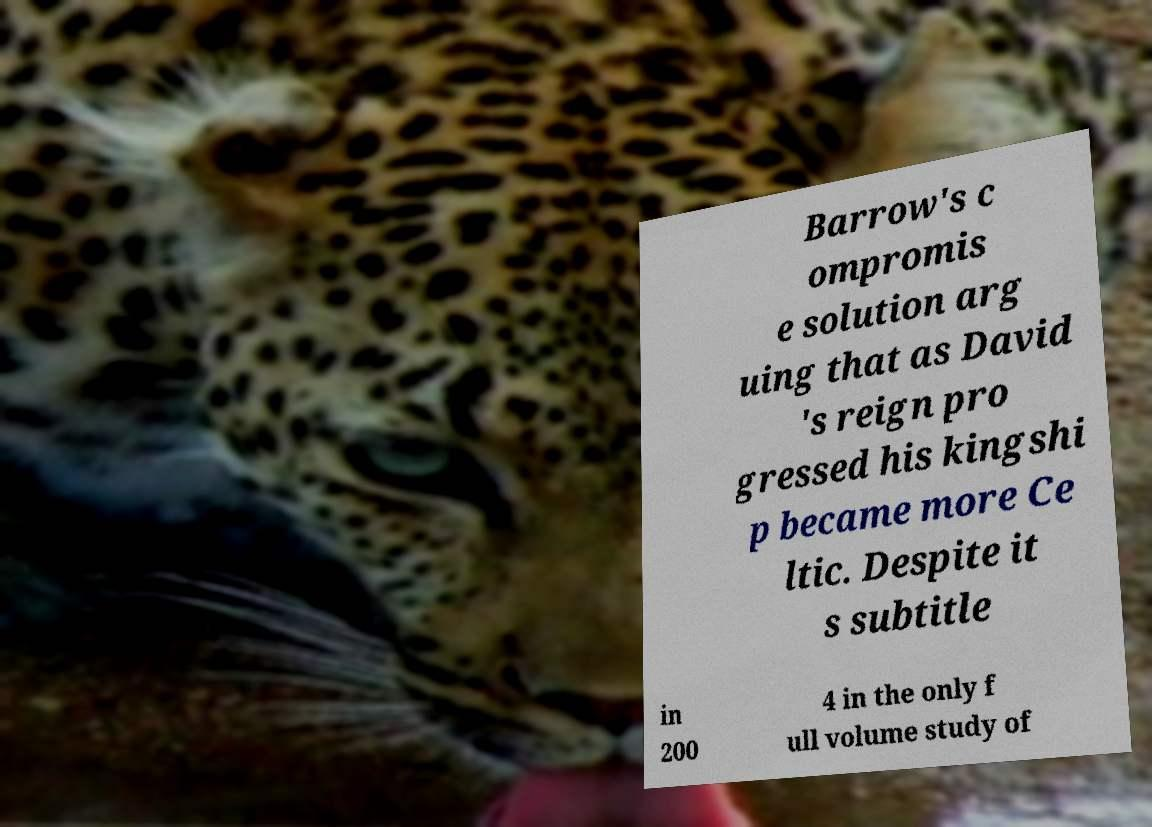For documentation purposes, I need the text within this image transcribed. Could you provide that? Barrow's c ompromis e solution arg uing that as David 's reign pro gressed his kingshi p became more Ce ltic. Despite it s subtitle in 200 4 in the only f ull volume study of 